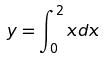<formula> <loc_0><loc_0><loc_500><loc_500>y = \int _ { 0 } ^ { 2 } x d x</formula> 